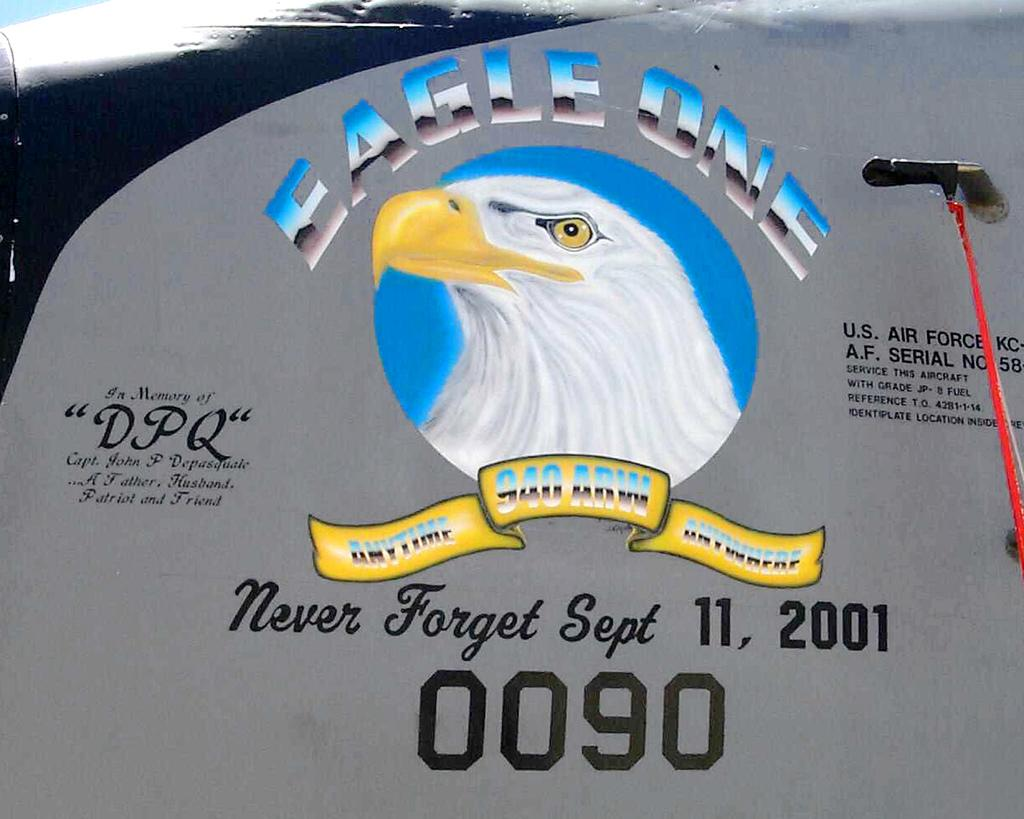What is the main object in the center of the image? There is a board in the center of the image. What can be seen on the board? There is text on the board. Is there any symbol or logo on the board? Yes, there is an emblem in the center of the image. What type of voice can be heard coming from the emblem in the image? There is no voice present in the image, as it is a static visual representation. 